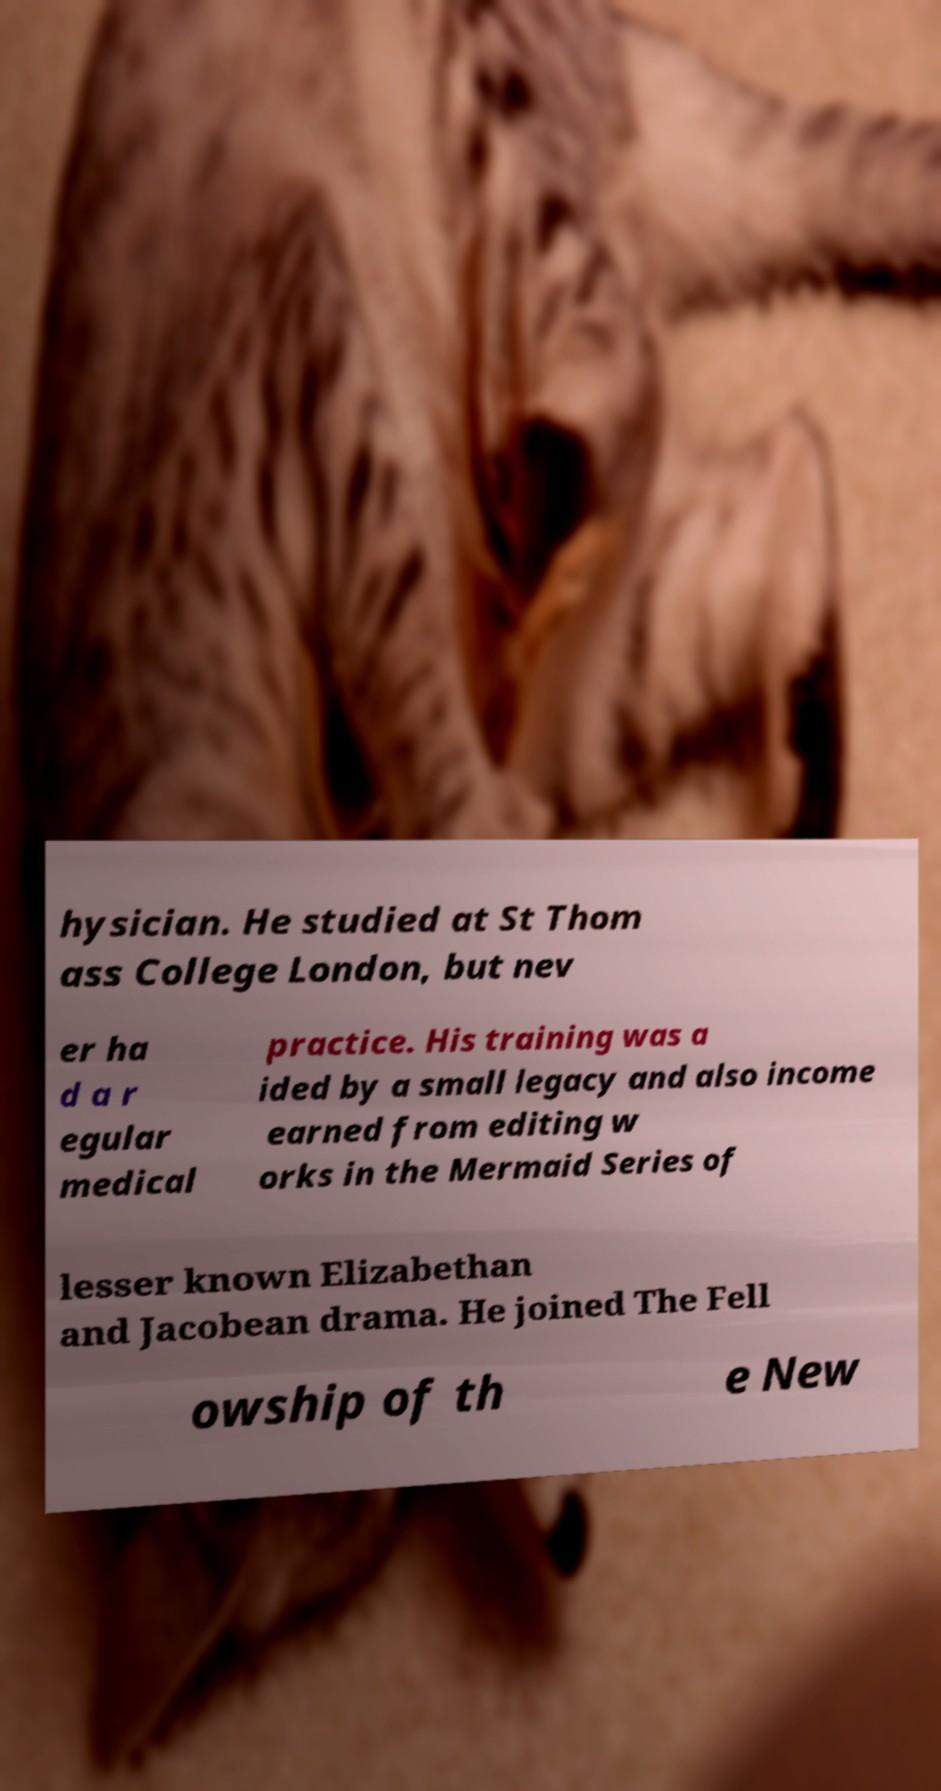There's text embedded in this image that I need extracted. Can you transcribe it verbatim? hysician. He studied at St Thom ass College London, but nev er ha d a r egular medical practice. His training was a ided by a small legacy and also income earned from editing w orks in the Mermaid Series of lesser known Elizabethan and Jacobean drama. He joined The Fell owship of th e New 